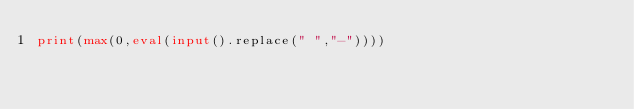Convert code to text. <code><loc_0><loc_0><loc_500><loc_500><_Python_>print(max(0,eval(input().replace(" ","-"))))
</code> 